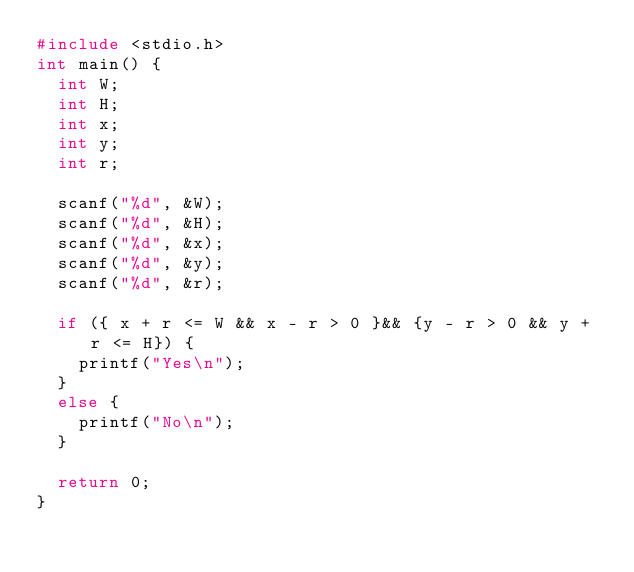Convert code to text. <code><loc_0><loc_0><loc_500><loc_500><_C_>#include <stdio.h>
int main() {
	int W;
	int H;
	int x;
	int y;
	int r;

	scanf("%d", &W);
	scanf("%d", &H);
	scanf("%d", &x);
	scanf("%d", &y);
	scanf("%d", &r);

	if ({ x + r <= W && x - r > 0 }&& {y - r > 0 && y + r <= H}) {
		printf("Yes\n");
	}
	else {
		printf("No\n");
	}

	return 0;
}
</code> 